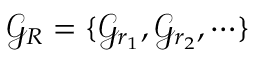<formula> <loc_0><loc_0><loc_500><loc_500>{ \mathcal { G } } _ { R } = \{ { \mathcal { G } } _ { r _ { 1 } } , { \mathcal { G } } _ { r _ { 2 } } , \cdots \}</formula> 